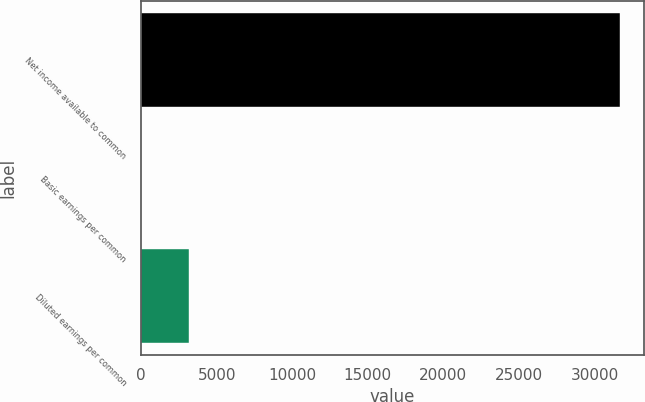Convert chart. <chart><loc_0><loc_0><loc_500><loc_500><bar_chart><fcel>Net income available to common<fcel>Basic earnings per common<fcel>Diluted earnings per common<nl><fcel>31705<fcel>1.31<fcel>3171.68<nl></chart> 